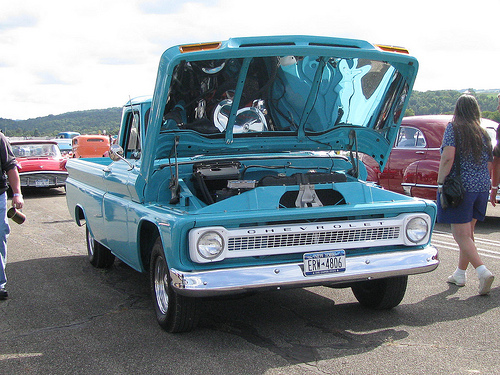<image>
Is the woman to the left of the car? No. The woman is not to the left of the car. From this viewpoint, they have a different horizontal relationship. 